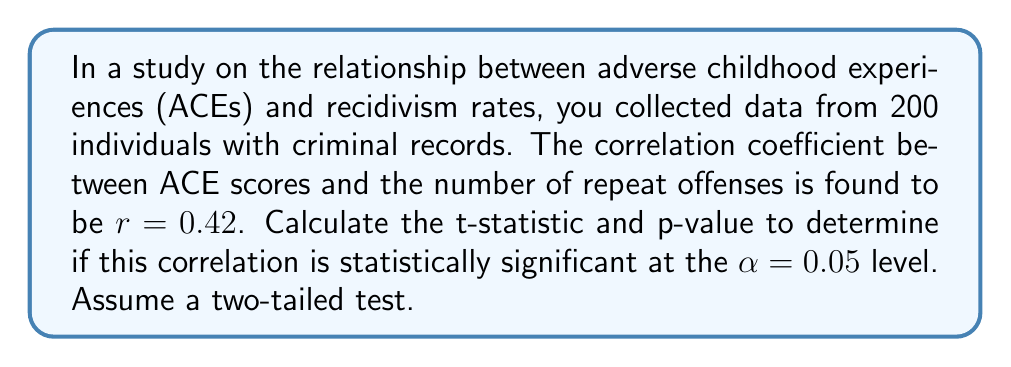What is the answer to this math problem? To determine the statistical significance of the correlation between ACE scores and recidivism rates, we need to calculate the t-statistic and p-value. Here's a step-by-step approach:

1. Given information:
   - Sample size: $n = 200$
   - Correlation coefficient: $r = 0.42$
   - Significance level: $\alpha = 0.05$
   - Two-tailed test

2. Calculate the t-statistic:
   The formula for the t-statistic in this case is:
   
   $$t = \frac{r\sqrt{n-2}}{\sqrt{1-r^2}}$$

   Substituting the values:
   
   $$t = \frac{0.42\sqrt{200-2}}{\sqrt{1-0.42^2}}$$
   
   $$t = \frac{0.42\sqrt{198}}{\sqrt{0.8236}}$$
   
   $$t = \frac{0.42 \cdot 14.0713}{0.9075}$$
   
   $$t = 6.5071$$

3. Determine the degrees of freedom:
   $df = n - 2 = 200 - 2 = 198$

4. Find the critical t-value:
   For a two-tailed test with $\alpha = 0.05$ and $df = 198$, the critical t-value is approximately $\pm 1.9719$ (this can be found using a t-distribution table or calculator).

5. Calculate the p-value:
   Using a t-distribution calculator or table, we find that the p-value for $t = 6.5071$ with $df = 198$ is $p < 0.0001$.

6. Interpret the results:
   Since the calculated t-statistic (6.5071) is greater than the critical t-value (1.9719) and the p-value ($< 0.0001$) is less than the significance level ($0.05$), we reject the null hypothesis.
Answer: t-statistic: $6.5071$
p-value: $p < 0.0001$

The correlation between ACE scores and recidivism rates is statistically significant at the $\alpha = 0.05$ level. 